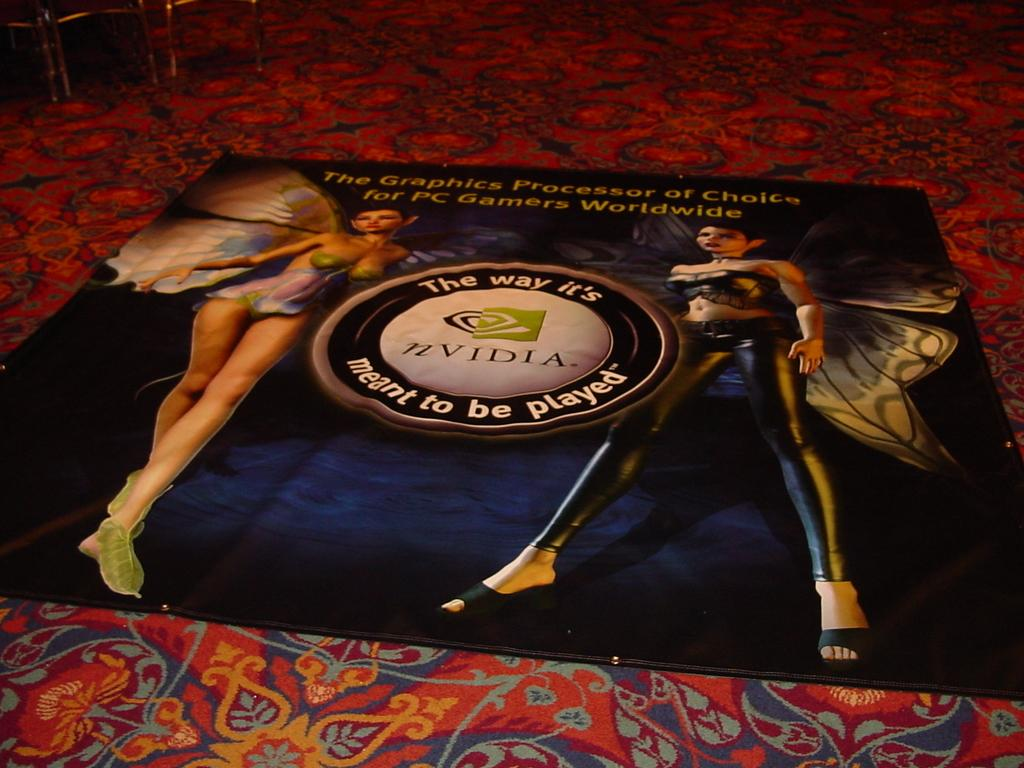What is on the carpet in the image? There is a cloth on the carpet in the image. Can you describe anything visible in the background of the image? Unfortunately, the provided facts do not give any specific details about the objects visible in the background. What type of juice can be seen flowing from the birds in the image? There are no birds or juice present in the image. 